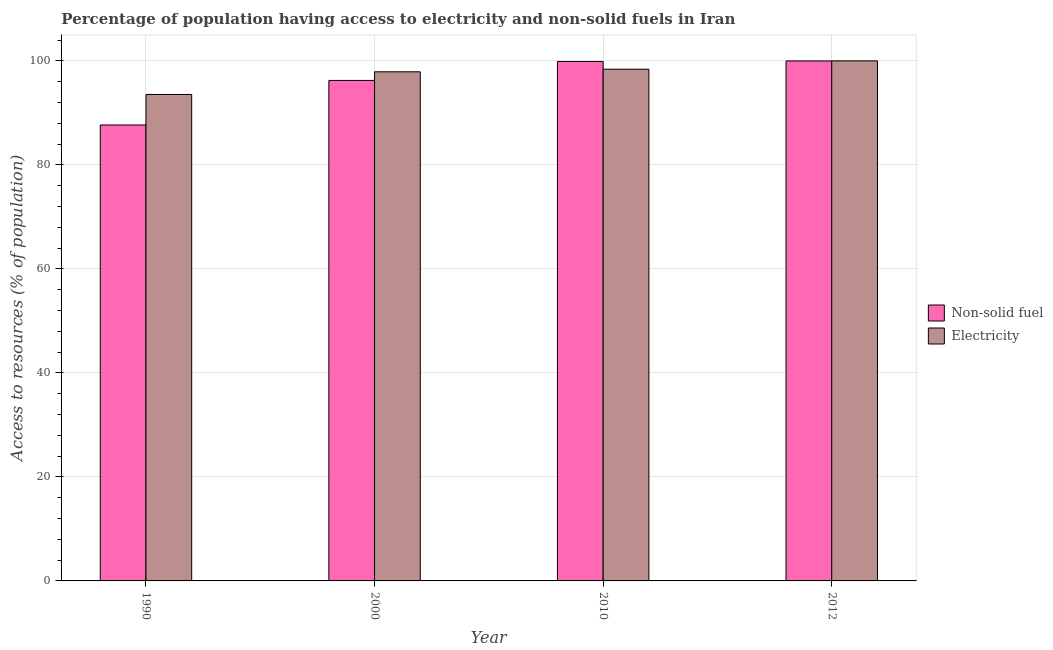How many groups of bars are there?
Offer a terse response. 4. Are the number of bars per tick equal to the number of legend labels?
Your response must be concise. Yes. In how many cases, is the number of bars for a given year not equal to the number of legend labels?
Provide a succinct answer. 0. What is the percentage of population having access to electricity in 1990?
Offer a very short reply. 93.54. Across all years, what is the maximum percentage of population having access to non-solid fuel?
Ensure brevity in your answer.  99.99. Across all years, what is the minimum percentage of population having access to electricity?
Provide a succinct answer. 93.54. In which year was the percentage of population having access to non-solid fuel minimum?
Make the answer very short. 1990. What is the total percentage of population having access to non-solid fuel in the graph?
Your answer should be compact. 383.78. What is the difference between the percentage of population having access to non-solid fuel in 1990 and the percentage of population having access to electricity in 2000?
Provide a short and direct response. -8.57. What is the average percentage of population having access to non-solid fuel per year?
Offer a very short reply. 95.95. What is the ratio of the percentage of population having access to non-solid fuel in 2000 to that in 2010?
Your response must be concise. 0.96. Is the difference between the percentage of population having access to non-solid fuel in 1990 and 2000 greater than the difference between the percentage of population having access to electricity in 1990 and 2000?
Make the answer very short. No. What is the difference between the highest and the second highest percentage of population having access to non-solid fuel?
Your answer should be compact. 0.11. What is the difference between the highest and the lowest percentage of population having access to electricity?
Keep it short and to the point. 6.46. Is the sum of the percentage of population having access to electricity in 2010 and 2012 greater than the maximum percentage of population having access to non-solid fuel across all years?
Offer a terse response. Yes. What does the 2nd bar from the left in 1990 represents?
Offer a terse response. Electricity. What does the 1st bar from the right in 2000 represents?
Your answer should be compact. Electricity. How many bars are there?
Provide a short and direct response. 8. Are all the bars in the graph horizontal?
Your response must be concise. No. What is the difference between two consecutive major ticks on the Y-axis?
Your answer should be very brief. 20. How many legend labels are there?
Ensure brevity in your answer.  2. How are the legend labels stacked?
Provide a succinct answer. Vertical. What is the title of the graph?
Give a very brief answer. Percentage of population having access to electricity and non-solid fuels in Iran. What is the label or title of the Y-axis?
Make the answer very short. Access to resources (% of population). What is the Access to resources (% of population) in Non-solid fuel in 1990?
Make the answer very short. 87.68. What is the Access to resources (% of population) in Electricity in 1990?
Make the answer very short. 93.54. What is the Access to resources (% of population) in Non-solid fuel in 2000?
Your answer should be very brief. 96.24. What is the Access to resources (% of population) of Electricity in 2000?
Ensure brevity in your answer.  97.9. What is the Access to resources (% of population) of Non-solid fuel in 2010?
Your answer should be very brief. 99.88. What is the Access to resources (% of population) in Electricity in 2010?
Make the answer very short. 98.4. What is the Access to resources (% of population) in Non-solid fuel in 2012?
Your response must be concise. 99.99. What is the Access to resources (% of population) of Electricity in 2012?
Keep it short and to the point. 100. Across all years, what is the maximum Access to resources (% of population) in Non-solid fuel?
Your answer should be compact. 99.99. Across all years, what is the minimum Access to resources (% of population) of Non-solid fuel?
Offer a very short reply. 87.68. Across all years, what is the minimum Access to resources (% of population) of Electricity?
Offer a terse response. 93.54. What is the total Access to resources (% of population) of Non-solid fuel in the graph?
Your answer should be compact. 383.78. What is the total Access to resources (% of population) of Electricity in the graph?
Your answer should be very brief. 389.84. What is the difference between the Access to resources (% of population) of Non-solid fuel in 1990 and that in 2000?
Your answer should be compact. -8.57. What is the difference between the Access to resources (% of population) in Electricity in 1990 and that in 2000?
Keep it short and to the point. -4.36. What is the difference between the Access to resources (% of population) of Non-solid fuel in 1990 and that in 2010?
Offer a terse response. -12.2. What is the difference between the Access to resources (% of population) of Electricity in 1990 and that in 2010?
Provide a short and direct response. -4.86. What is the difference between the Access to resources (% of population) of Non-solid fuel in 1990 and that in 2012?
Make the answer very short. -12.31. What is the difference between the Access to resources (% of population) in Electricity in 1990 and that in 2012?
Provide a short and direct response. -6.46. What is the difference between the Access to resources (% of population) of Non-solid fuel in 2000 and that in 2010?
Offer a very short reply. -3.64. What is the difference between the Access to resources (% of population) of Non-solid fuel in 2000 and that in 2012?
Provide a short and direct response. -3.75. What is the difference between the Access to resources (% of population) of Non-solid fuel in 2010 and that in 2012?
Offer a terse response. -0.11. What is the difference between the Access to resources (% of population) of Electricity in 2010 and that in 2012?
Offer a very short reply. -1.6. What is the difference between the Access to resources (% of population) in Non-solid fuel in 1990 and the Access to resources (% of population) in Electricity in 2000?
Offer a very short reply. -10.22. What is the difference between the Access to resources (% of population) in Non-solid fuel in 1990 and the Access to resources (% of population) in Electricity in 2010?
Make the answer very short. -10.72. What is the difference between the Access to resources (% of population) in Non-solid fuel in 1990 and the Access to resources (% of population) in Electricity in 2012?
Give a very brief answer. -12.32. What is the difference between the Access to resources (% of population) of Non-solid fuel in 2000 and the Access to resources (% of population) of Electricity in 2010?
Give a very brief answer. -2.16. What is the difference between the Access to resources (% of population) of Non-solid fuel in 2000 and the Access to resources (% of population) of Electricity in 2012?
Your answer should be very brief. -3.76. What is the difference between the Access to resources (% of population) in Non-solid fuel in 2010 and the Access to resources (% of population) in Electricity in 2012?
Offer a terse response. -0.12. What is the average Access to resources (% of population) of Non-solid fuel per year?
Your answer should be compact. 95.95. What is the average Access to resources (% of population) of Electricity per year?
Keep it short and to the point. 97.46. In the year 1990, what is the difference between the Access to resources (% of population) of Non-solid fuel and Access to resources (% of population) of Electricity?
Give a very brief answer. -5.86. In the year 2000, what is the difference between the Access to resources (% of population) in Non-solid fuel and Access to resources (% of population) in Electricity?
Your answer should be very brief. -1.66. In the year 2010, what is the difference between the Access to resources (% of population) of Non-solid fuel and Access to resources (% of population) of Electricity?
Give a very brief answer. 1.48. In the year 2012, what is the difference between the Access to resources (% of population) of Non-solid fuel and Access to resources (% of population) of Electricity?
Your answer should be compact. -0.01. What is the ratio of the Access to resources (% of population) of Non-solid fuel in 1990 to that in 2000?
Your answer should be compact. 0.91. What is the ratio of the Access to resources (% of population) of Electricity in 1990 to that in 2000?
Your answer should be very brief. 0.96. What is the ratio of the Access to resources (% of population) in Non-solid fuel in 1990 to that in 2010?
Provide a succinct answer. 0.88. What is the ratio of the Access to resources (% of population) in Electricity in 1990 to that in 2010?
Your response must be concise. 0.95. What is the ratio of the Access to resources (% of population) in Non-solid fuel in 1990 to that in 2012?
Offer a very short reply. 0.88. What is the ratio of the Access to resources (% of population) of Electricity in 1990 to that in 2012?
Offer a terse response. 0.94. What is the ratio of the Access to resources (% of population) of Non-solid fuel in 2000 to that in 2010?
Provide a succinct answer. 0.96. What is the ratio of the Access to resources (% of population) in Electricity in 2000 to that in 2010?
Your answer should be very brief. 0.99. What is the ratio of the Access to resources (% of population) of Non-solid fuel in 2000 to that in 2012?
Your answer should be compact. 0.96. What is the ratio of the Access to resources (% of population) of Non-solid fuel in 2010 to that in 2012?
Provide a succinct answer. 1. What is the difference between the highest and the second highest Access to resources (% of population) in Non-solid fuel?
Make the answer very short. 0.11. What is the difference between the highest and the lowest Access to resources (% of population) in Non-solid fuel?
Ensure brevity in your answer.  12.31. What is the difference between the highest and the lowest Access to resources (% of population) in Electricity?
Make the answer very short. 6.46. 